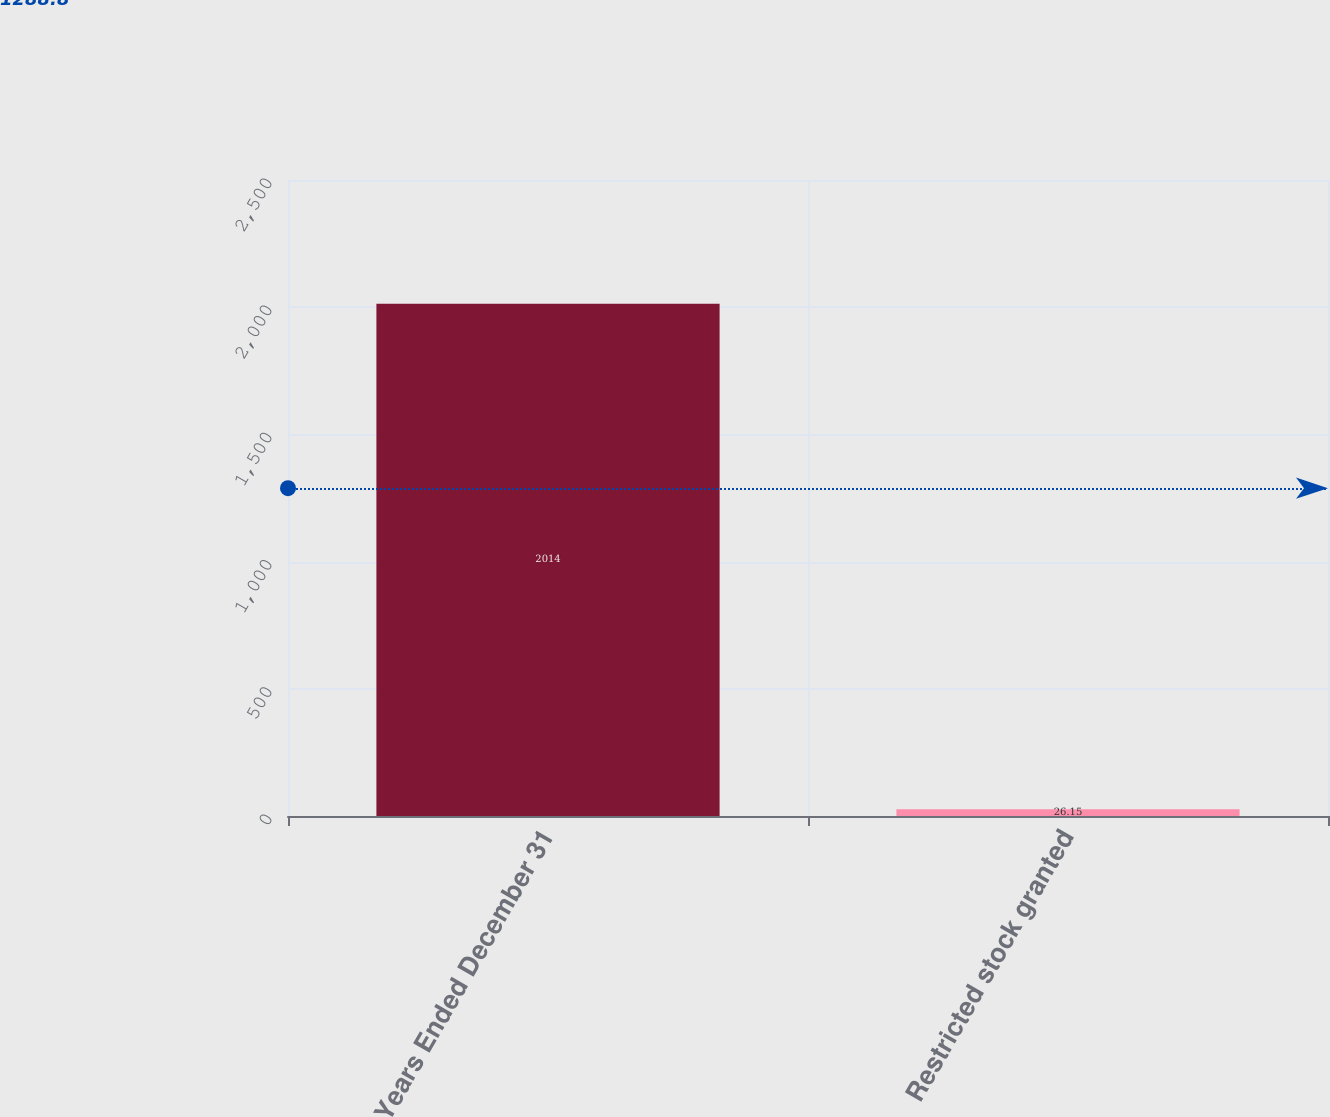Convert chart. <chart><loc_0><loc_0><loc_500><loc_500><bar_chart><fcel>Years Ended December 31<fcel>Restricted stock granted<nl><fcel>2014<fcel>26.15<nl></chart> 